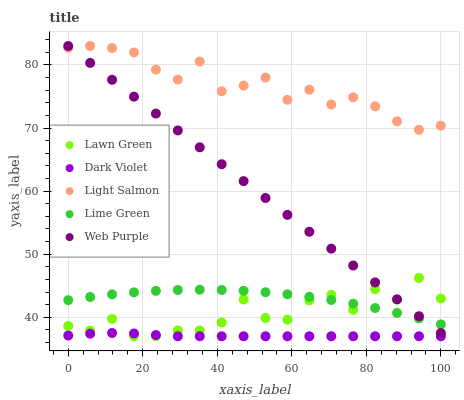Does Dark Violet have the minimum area under the curve?
Answer yes or no. Yes. Does Light Salmon have the maximum area under the curve?
Answer yes or no. Yes. Does Lime Green have the minimum area under the curve?
Answer yes or no. No. Does Lime Green have the maximum area under the curve?
Answer yes or no. No. Is Web Purple the smoothest?
Answer yes or no. Yes. Is Lawn Green the roughest?
Answer yes or no. Yes. Is Light Salmon the smoothest?
Answer yes or no. No. Is Light Salmon the roughest?
Answer yes or no. No. Does Lawn Green have the lowest value?
Answer yes or no. Yes. Does Lime Green have the lowest value?
Answer yes or no. No. Does Web Purple have the highest value?
Answer yes or no. Yes. Does Lime Green have the highest value?
Answer yes or no. No. Is Lawn Green less than Light Salmon?
Answer yes or no. Yes. Is Light Salmon greater than Lawn Green?
Answer yes or no. Yes. Does Lime Green intersect Lawn Green?
Answer yes or no. Yes. Is Lime Green less than Lawn Green?
Answer yes or no. No. Is Lime Green greater than Lawn Green?
Answer yes or no. No. Does Lawn Green intersect Light Salmon?
Answer yes or no. No. 